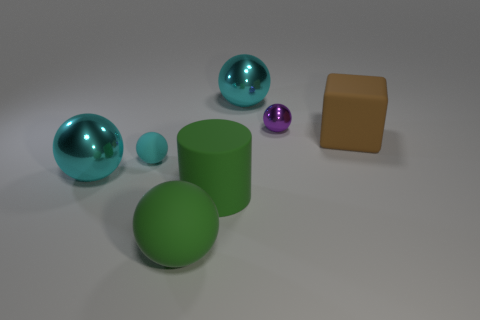Subtract all cyan spheres. How many were subtracted if there are1cyan spheres left? 2 Subtract all big cyan balls. How many balls are left? 3 Subtract all green blocks. How many cyan spheres are left? 3 Add 1 big rubber blocks. How many objects exist? 8 Subtract all purple spheres. How many spheres are left? 4 Subtract 2 spheres. How many spheres are left? 3 Subtract 0 gray cylinders. How many objects are left? 7 Subtract all cylinders. How many objects are left? 6 Subtract all gray cylinders. Subtract all blue blocks. How many cylinders are left? 1 Subtract all large blue cylinders. Subtract all large brown blocks. How many objects are left? 6 